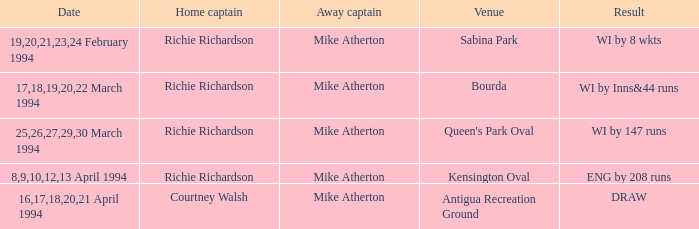When did a Venue of Antigua Recreation Ground happen? 16,17,18,20,21 April 1994. Parse the table in full. {'header': ['Date', 'Home captain', 'Away captain', 'Venue', 'Result'], 'rows': [['19,20,21,23,24 February 1994', 'Richie Richardson', 'Mike Atherton', 'Sabina Park', 'WI by 8 wkts'], ['17,18,19,20,22 March 1994', 'Richie Richardson', 'Mike Atherton', 'Bourda', 'WI by Inns&44 runs'], ['25,26,27,29,30 March 1994', 'Richie Richardson', 'Mike Atherton', "Queen's Park Oval", 'WI by 147 runs'], ['8,9,10,12,13 April 1994', 'Richie Richardson', 'Mike Atherton', 'Kensington Oval', 'ENG by 208 runs'], ['16,17,18,20,21 April 1994', 'Courtney Walsh', 'Mike Atherton', 'Antigua Recreation Ground', 'DRAW']]} 